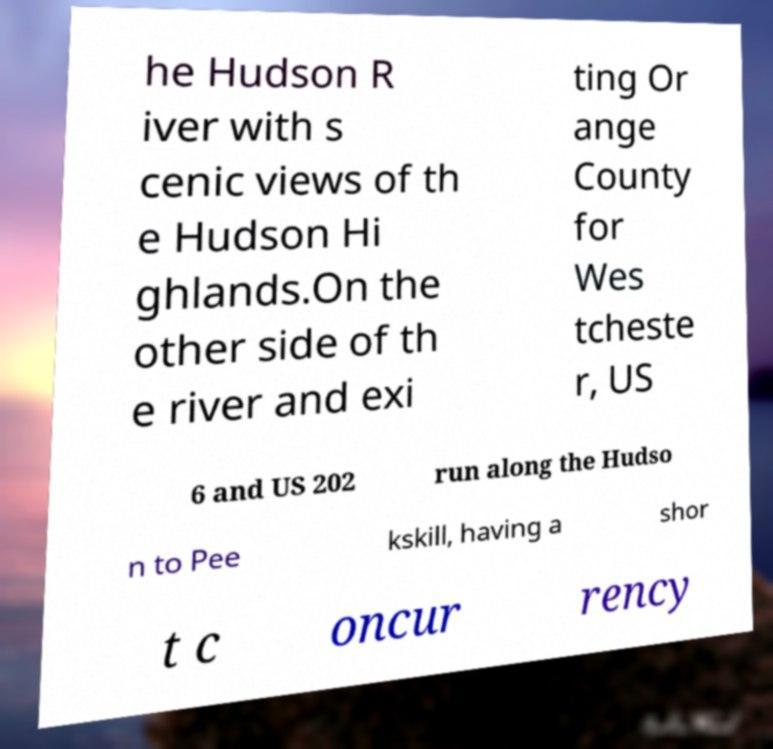There's text embedded in this image that I need extracted. Can you transcribe it verbatim? he Hudson R iver with s cenic views of th e Hudson Hi ghlands.On the other side of th e river and exi ting Or ange County for Wes tcheste r, US 6 and US 202 run along the Hudso n to Pee kskill, having a shor t c oncur rency 